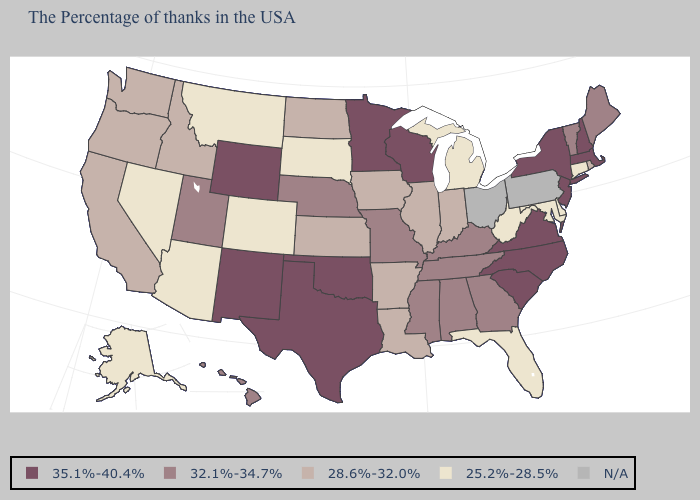What is the highest value in the Northeast ?
Short answer required. 35.1%-40.4%. Which states have the lowest value in the USA?
Write a very short answer. Connecticut, Delaware, Maryland, West Virginia, Florida, Michigan, South Dakota, Colorado, Montana, Arizona, Nevada, Alaska. What is the lowest value in the West?
Short answer required. 25.2%-28.5%. What is the value of Vermont?
Quick response, please. 32.1%-34.7%. Name the states that have a value in the range N/A?
Quick response, please. Pennsylvania, Ohio. Name the states that have a value in the range 28.6%-32.0%?
Answer briefly. Rhode Island, Indiana, Illinois, Louisiana, Arkansas, Iowa, Kansas, North Dakota, Idaho, California, Washington, Oregon. Name the states that have a value in the range N/A?
Be succinct. Pennsylvania, Ohio. What is the value of Wisconsin?
Quick response, please. 35.1%-40.4%. What is the value of Kentucky?
Quick response, please. 32.1%-34.7%. Which states have the lowest value in the USA?
Answer briefly. Connecticut, Delaware, Maryland, West Virginia, Florida, Michigan, South Dakota, Colorado, Montana, Arizona, Nevada, Alaska. Among the states that border Pennsylvania , does New York have the highest value?
Answer briefly. Yes. Among the states that border Iowa , does Nebraska have the highest value?
Give a very brief answer. No. Name the states that have a value in the range 35.1%-40.4%?
Write a very short answer. Massachusetts, New Hampshire, New York, New Jersey, Virginia, North Carolina, South Carolina, Wisconsin, Minnesota, Oklahoma, Texas, Wyoming, New Mexico. What is the highest value in the Northeast ?
Concise answer only. 35.1%-40.4%. Which states hav the highest value in the MidWest?
Answer briefly. Wisconsin, Minnesota. 